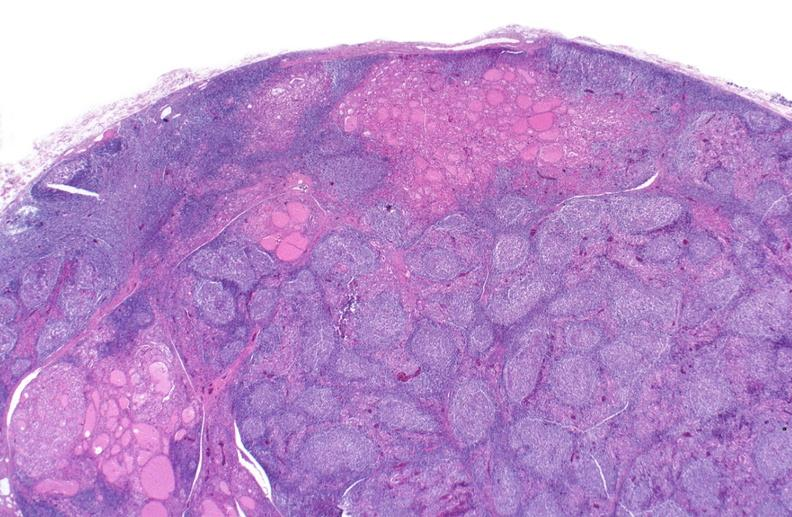does this image show hashimoto 's thyroiditis?
Answer the question using a single word or phrase. Yes 